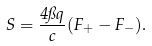<formula> <loc_0><loc_0><loc_500><loc_500>S = \frac { 4 \pi q } { c } ( F _ { + } - F _ { - } ) .</formula> 